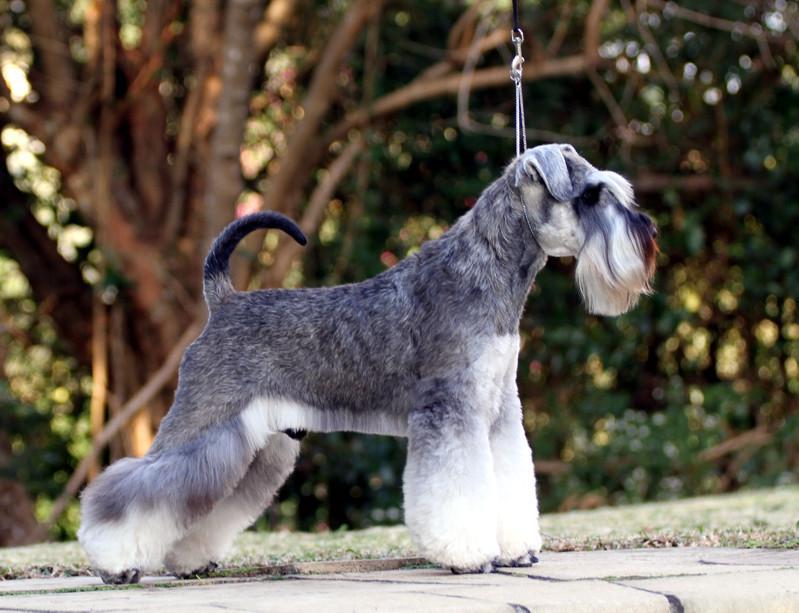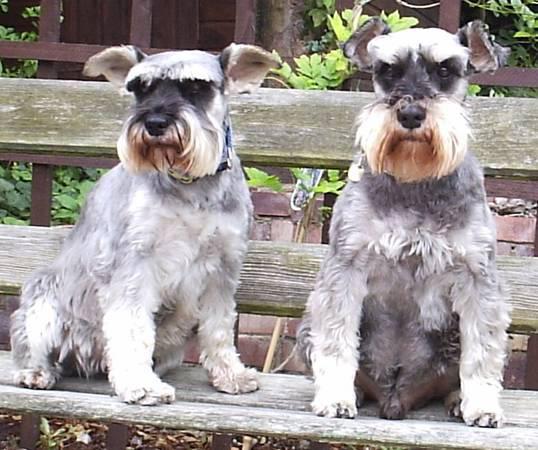The first image is the image on the left, the second image is the image on the right. Evaluate the accuracy of this statement regarding the images: "a dog is posing with a taught loop around it's neck". Is it true? Answer yes or no. Yes. The first image is the image on the left, the second image is the image on the right. Given the left and right images, does the statement "There are three Schnauzers in one image, and one in the other." hold true? Answer yes or no. No. 